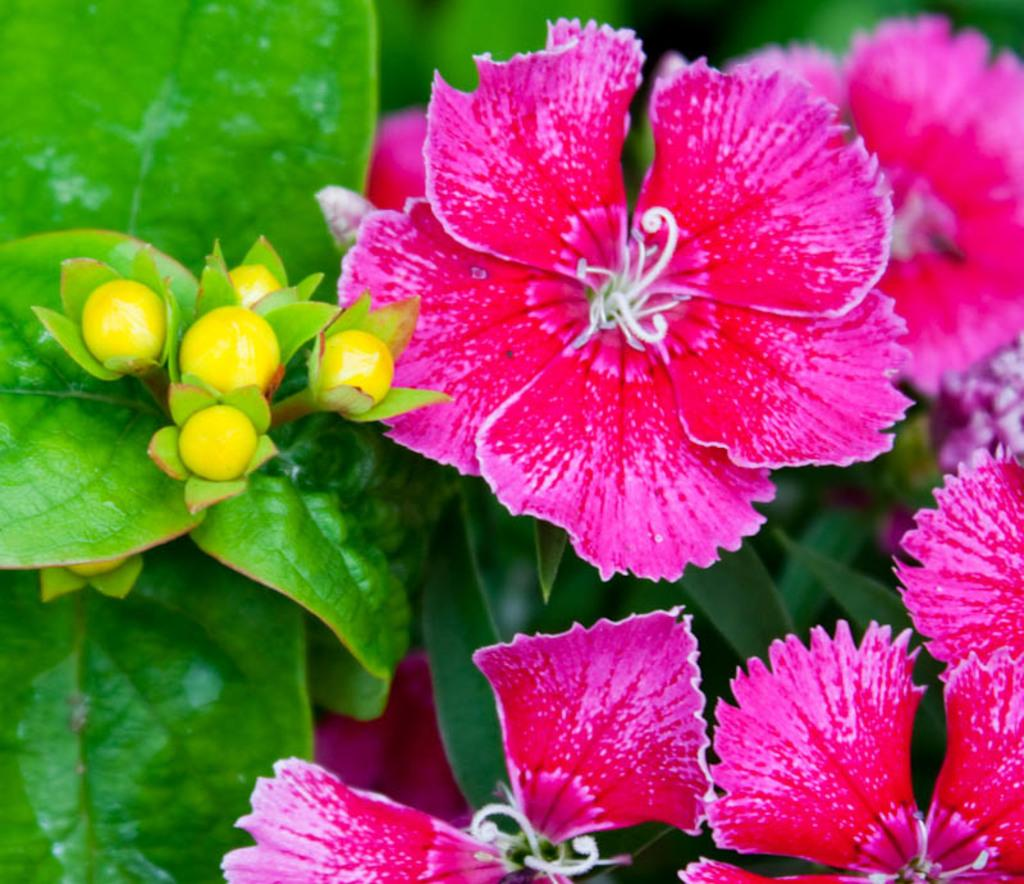What type of flowers are present in the image? There are pink flowers in the image. What else can be seen near the flowers? There are leaves beside the flowers in the image. What type of spy equipment can be seen in the image? There is no spy equipment present in the image; it features pink flowers and leaves. Is there a church visible in the image? There is no church present in the image; it only contains pink flowers and leaves. 